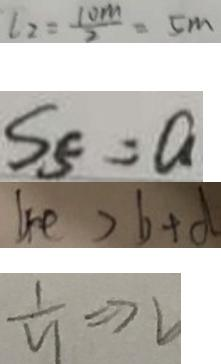<formula> <loc_0><loc_0><loc_500><loc_500>l _ { 2 } = \frac { 1 0 m } { 2 } = 5 m 
 S _ { 5 } = a 
 4 e > b + d 
 \frac { 1 } { y } \Rightarrow 2</formula> 